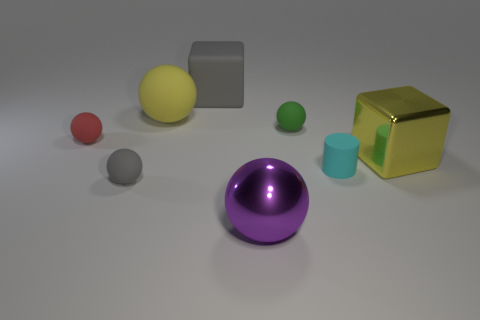Subtract all purple balls. How many balls are left? 4 Add 1 small cyan shiny balls. How many objects exist? 9 Subtract all cylinders. How many objects are left? 7 Subtract all red spheres. How many spheres are left? 4 Subtract all brown cylinders. How many yellow blocks are left? 1 Subtract all red rubber balls. Subtract all small red spheres. How many objects are left? 6 Add 7 big gray cubes. How many big gray cubes are left? 8 Add 8 green things. How many green things exist? 9 Subtract 1 gray balls. How many objects are left? 7 Subtract 3 balls. How many balls are left? 2 